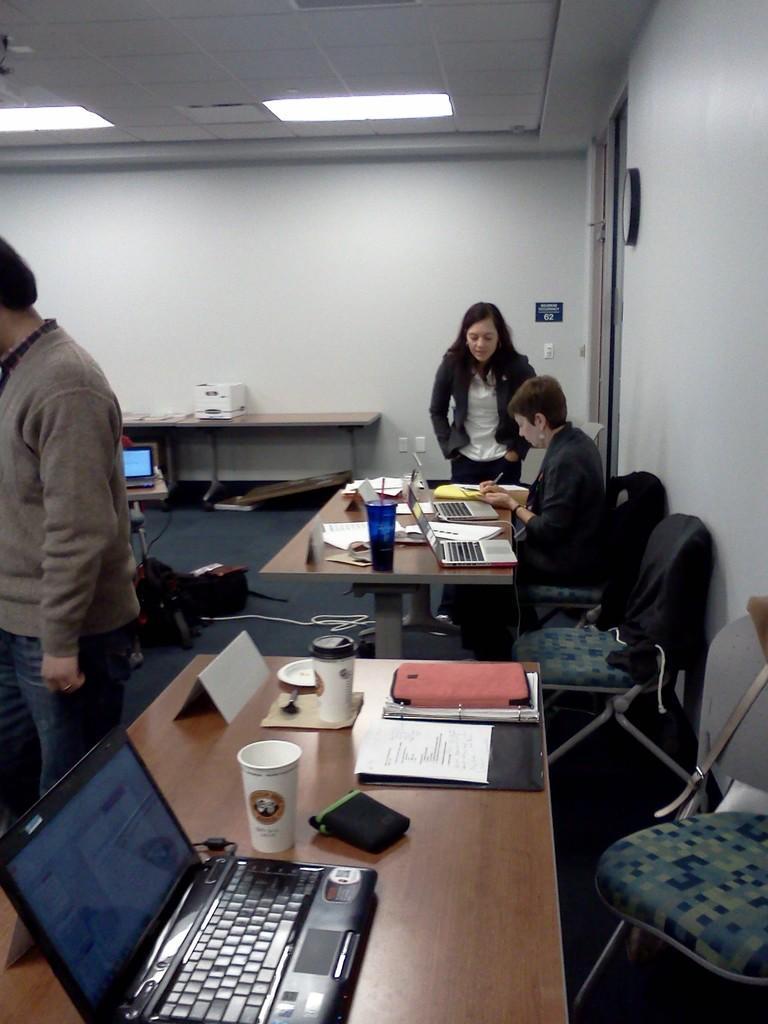How would you summarize this image in a sentence or two? In this image there is a woman standing , another woman sitting in chair and writing in a paper , and on table there are glasses, papers, books,laptops, and at the back ground there is another person standing at the left side corner, wall, lights, door, frame. 